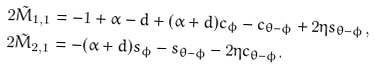<formula> <loc_0><loc_0><loc_500><loc_500>2 \tilde { M } _ { 1 , 1 } & = - 1 + \alpha - d + ( \alpha + d ) c _ { \phi } - c _ { \theta - \phi } + 2 \eta s _ { \theta - \phi } , \\ 2 \tilde { M } _ { 2 , 1 } & = - ( \alpha + d ) s _ { \phi } - s _ { \theta - \phi } - 2 \eta c _ { \theta - \phi } .</formula> 